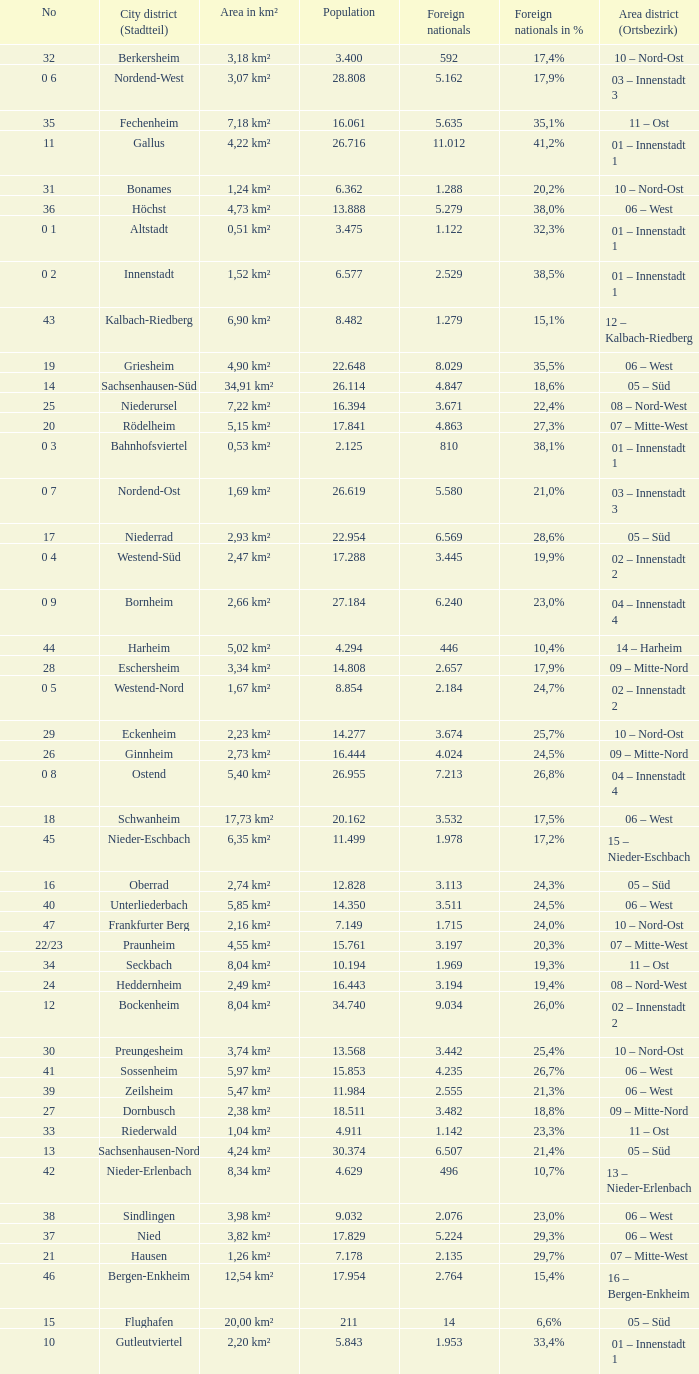How many foreigners in percentage terms had a population of 4.911? 1.0. 